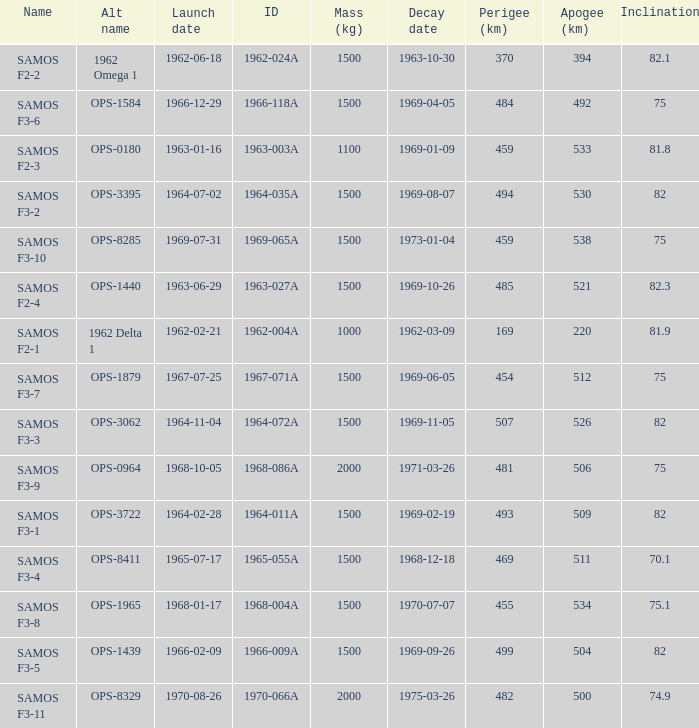How many alt names does 1964-011a have? 1.0. 